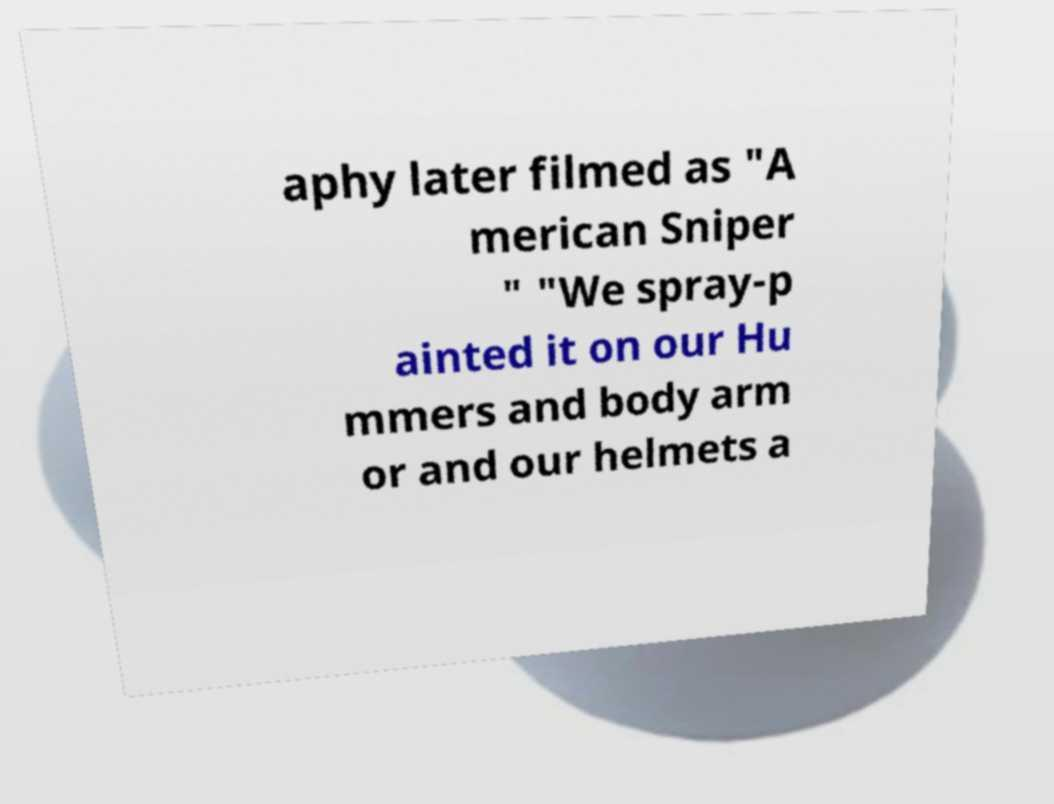Could you extract and type out the text from this image? aphy later filmed as "A merican Sniper " "We spray-p ainted it on our Hu mmers and body arm or and our helmets a 